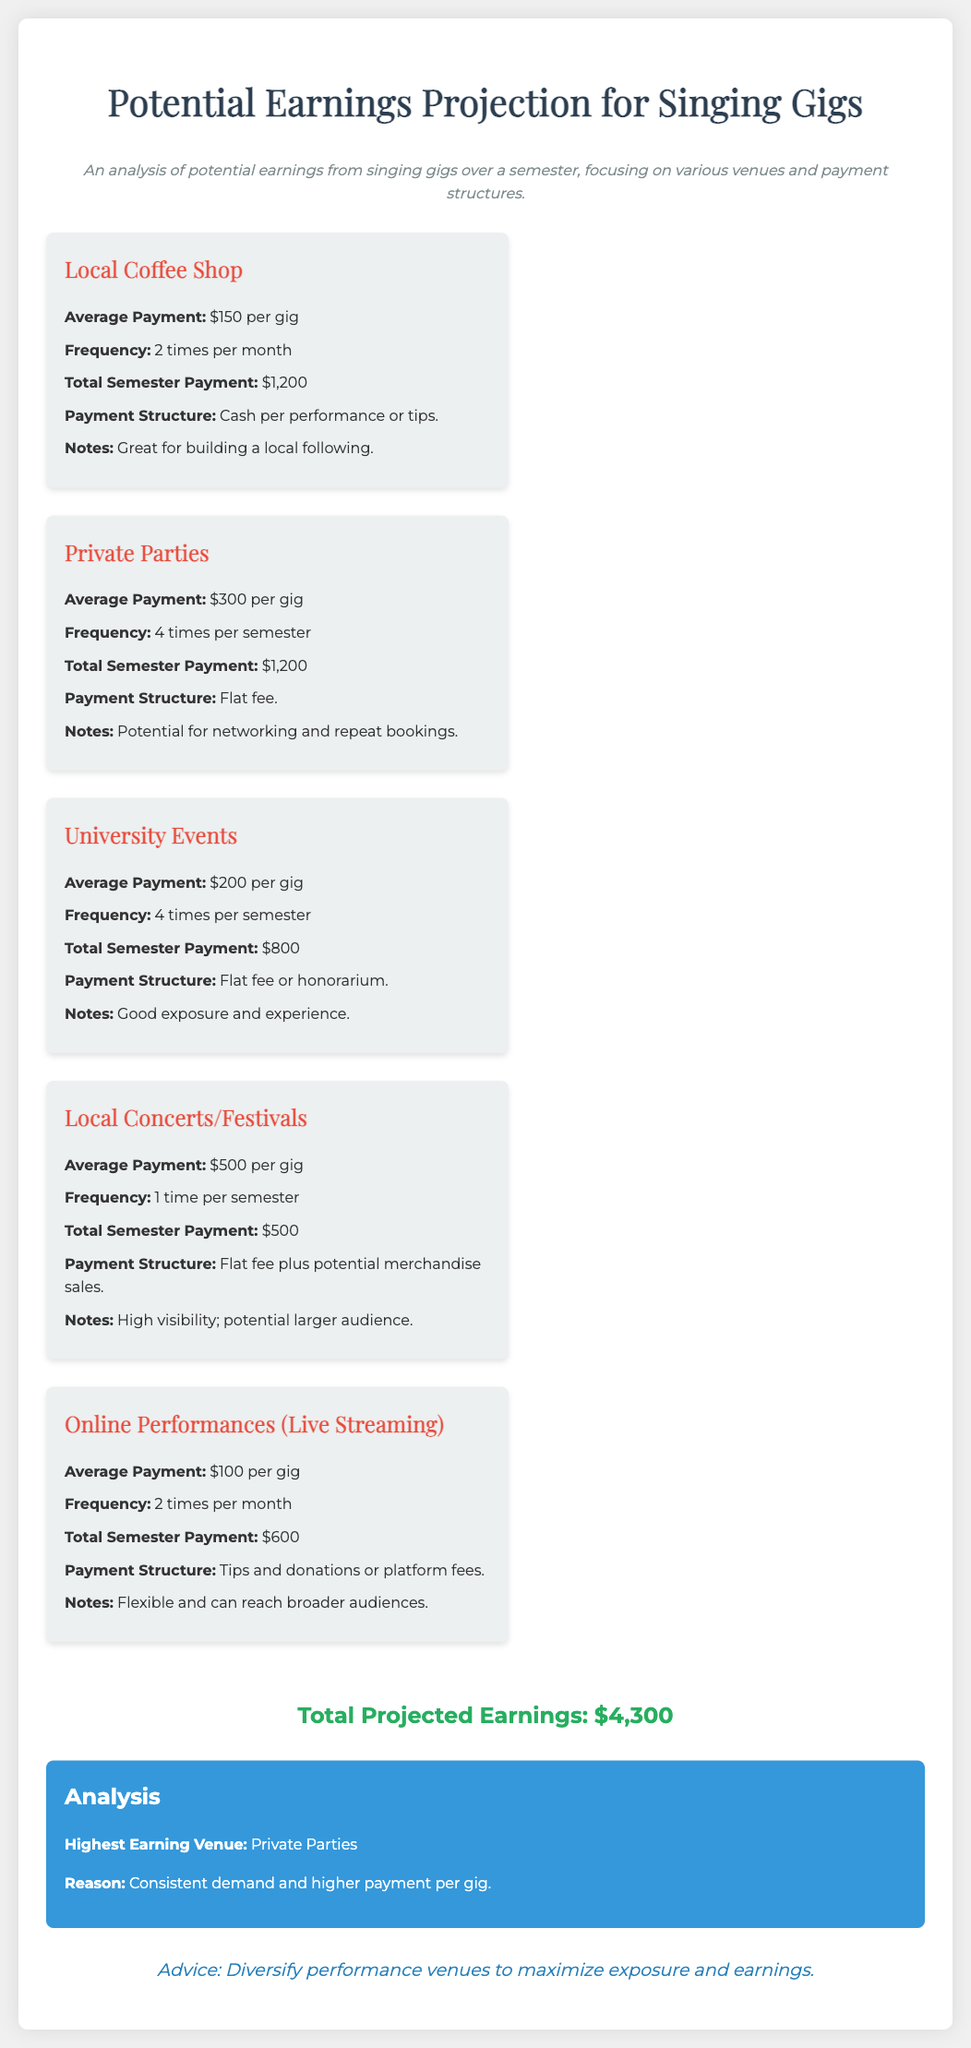what is the total projected earnings? The total projected earnings is shown clearly at the end of the document, summing all the potential earnings from various venues.
Answer: $4,300 how often are gigs held at the local coffee shop? The document specifies that gigs at the local coffee shop occur two times per month.
Answer: 2 times per month what is the average payment for private parties? The average payment for private parties is detailed in the document as a specific monetary amount.
Answer: $300 which venue has the highest earning potential? The analysis section highlights the venue with the best earnings based on its average payment and frequency.
Answer: Private Parties how many total performances are scheduled for university events? The document indicates the frequency of university events to calculate the total performances over the semester.
Answer: 4 times what is a unique characteristic of online performances? The notes section under online performances describes their ability to reach a broader audience.
Answer: Flexible what payment structure is used for local concerts/festivals? The payment structure for this venue is stated as a specific type in the document, summarizing how artists are compensated.
Answer: Flat fee plus potential merchandise sales how much is earned per gig at the local concerts/festivals? The average payment per gig for local concerts/festivals is given clearly in the text.
Answer: $500 what advice is provided regarding performance venues? The advice section gives insight into the best strategy for maximizing performance opportunities and earnings.
Answer: Diversify performance venues 